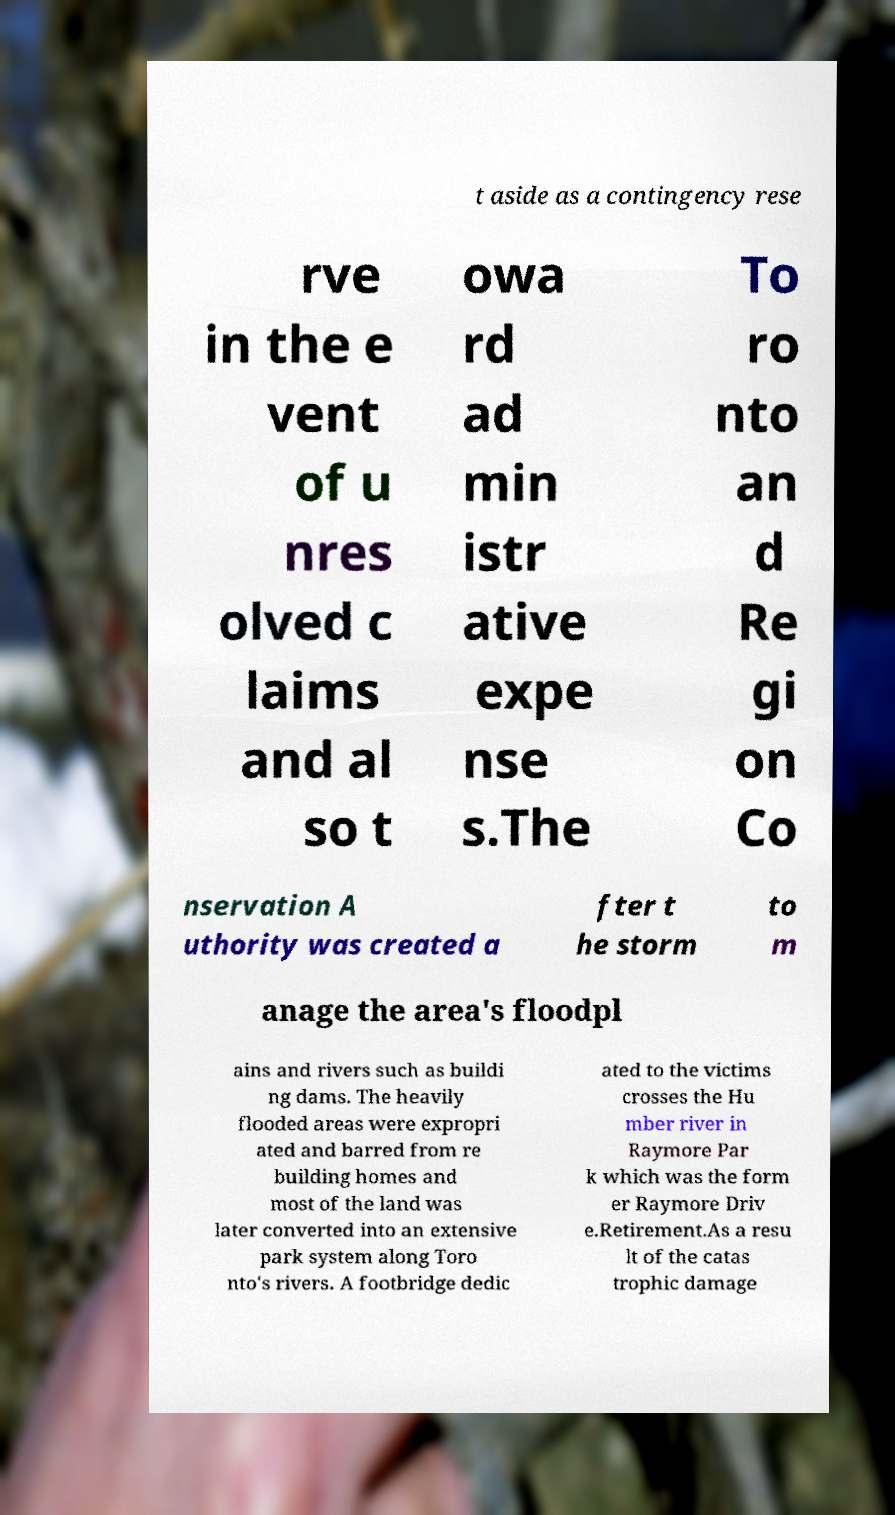There's text embedded in this image that I need extracted. Can you transcribe it verbatim? t aside as a contingency rese rve in the e vent of u nres olved c laims and al so t owa rd ad min istr ative expe nse s.The To ro nto an d Re gi on Co nservation A uthority was created a fter t he storm to m anage the area's floodpl ains and rivers such as buildi ng dams. The heavily flooded areas were expropri ated and barred from re building homes and most of the land was later converted into an extensive park system along Toro nto's rivers. A footbridge dedic ated to the victims crosses the Hu mber river in Raymore Par k which was the form er Raymore Driv e.Retirement.As a resu lt of the catas trophic damage 